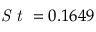<formula> <loc_0><loc_0><loc_500><loc_500>S t = 0 . 1 6 4 9</formula> 